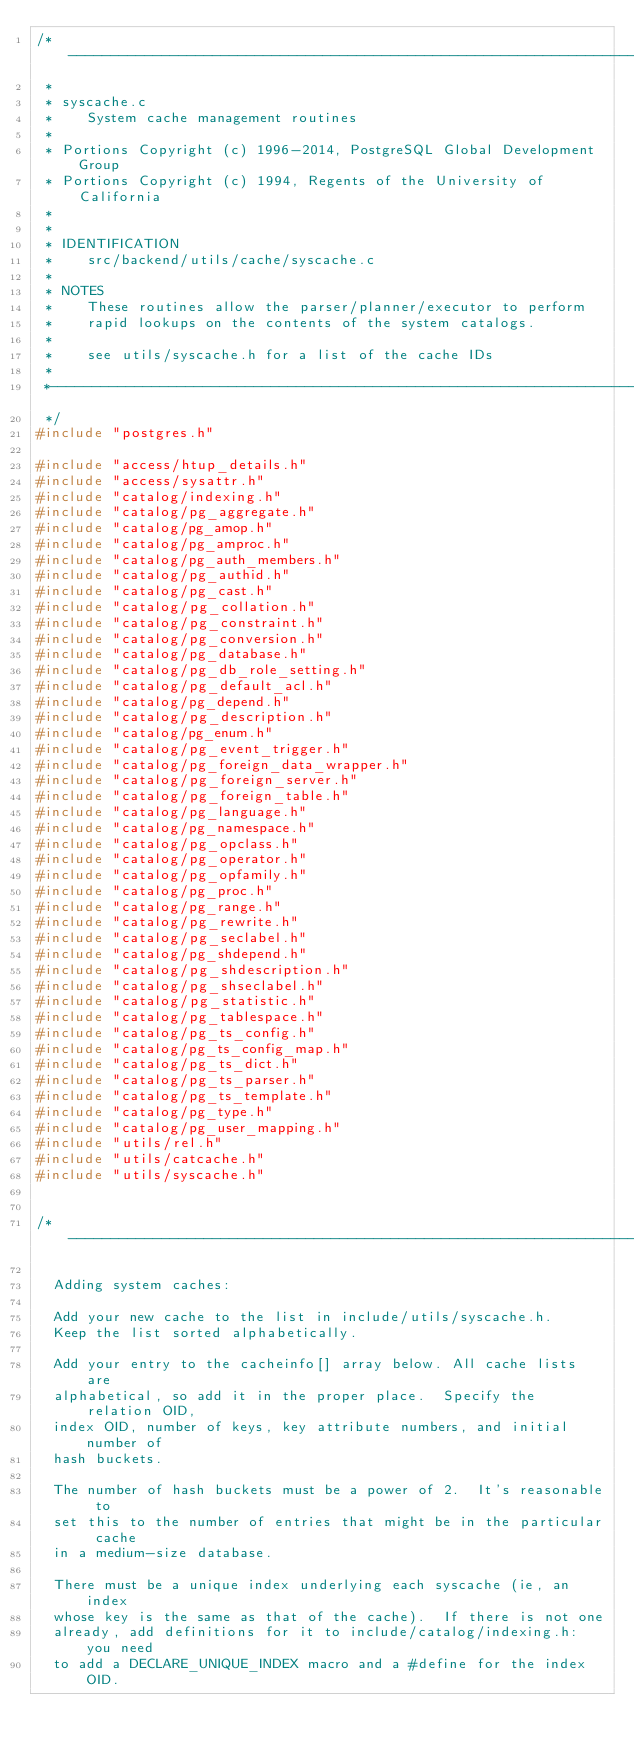<code> <loc_0><loc_0><loc_500><loc_500><_C_>/*-------------------------------------------------------------------------
 *
 * syscache.c
 *	  System cache management routines
 *
 * Portions Copyright (c) 1996-2014, PostgreSQL Global Development Group
 * Portions Copyright (c) 1994, Regents of the University of California
 *
 *
 * IDENTIFICATION
 *	  src/backend/utils/cache/syscache.c
 *
 * NOTES
 *	  These routines allow the parser/planner/executor to perform
 *	  rapid lookups on the contents of the system catalogs.
 *
 *	  see utils/syscache.h for a list of the cache IDs
 *
 *-------------------------------------------------------------------------
 */
#include "postgres.h"

#include "access/htup_details.h"
#include "access/sysattr.h"
#include "catalog/indexing.h"
#include "catalog/pg_aggregate.h"
#include "catalog/pg_amop.h"
#include "catalog/pg_amproc.h"
#include "catalog/pg_auth_members.h"
#include "catalog/pg_authid.h"
#include "catalog/pg_cast.h"
#include "catalog/pg_collation.h"
#include "catalog/pg_constraint.h"
#include "catalog/pg_conversion.h"
#include "catalog/pg_database.h"
#include "catalog/pg_db_role_setting.h"
#include "catalog/pg_default_acl.h"
#include "catalog/pg_depend.h"
#include "catalog/pg_description.h"
#include "catalog/pg_enum.h"
#include "catalog/pg_event_trigger.h"
#include "catalog/pg_foreign_data_wrapper.h"
#include "catalog/pg_foreign_server.h"
#include "catalog/pg_foreign_table.h"
#include "catalog/pg_language.h"
#include "catalog/pg_namespace.h"
#include "catalog/pg_opclass.h"
#include "catalog/pg_operator.h"
#include "catalog/pg_opfamily.h"
#include "catalog/pg_proc.h"
#include "catalog/pg_range.h"
#include "catalog/pg_rewrite.h"
#include "catalog/pg_seclabel.h"
#include "catalog/pg_shdepend.h"
#include "catalog/pg_shdescription.h"
#include "catalog/pg_shseclabel.h"
#include "catalog/pg_statistic.h"
#include "catalog/pg_tablespace.h"
#include "catalog/pg_ts_config.h"
#include "catalog/pg_ts_config_map.h"
#include "catalog/pg_ts_dict.h"
#include "catalog/pg_ts_parser.h"
#include "catalog/pg_ts_template.h"
#include "catalog/pg_type.h"
#include "catalog/pg_user_mapping.h"
#include "utils/rel.h"
#include "utils/catcache.h"
#include "utils/syscache.h"


/*---------------------------------------------------------------------------

	Adding system caches:

	Add your new cache to the list in include/utils/syscache.h.
	Keep the list sorted alphabetically.

	Add your entry to the cacheinfo[] array below. All cache lists are
	alphabetical, so add it in the proper place.  Specify the relation OID,
	index OID, number of keys, key attribute numbers, and initial number of
	hash buckets.

	The number of hash buckets must be a power of 2.  It's reasonable to
	set this to the number of entries that might be in the particular cache
	in a medium-size database.

	There must be a unique index underlying each syscache (ie, an index
	whose key is the same as that of the cache).  If there is not one
	already, add definitions for it to include/catalog/indexing.h: you need
	to add a DECLARE_UNIQUE_INDEX macro and a #define for the index OID.</code> 